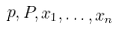Convert formula to latex. <formula><loc_0><loc_0><loc_500><loc_500>p , P , x _ { 1 } , \dots , x _ { n }</formula> 